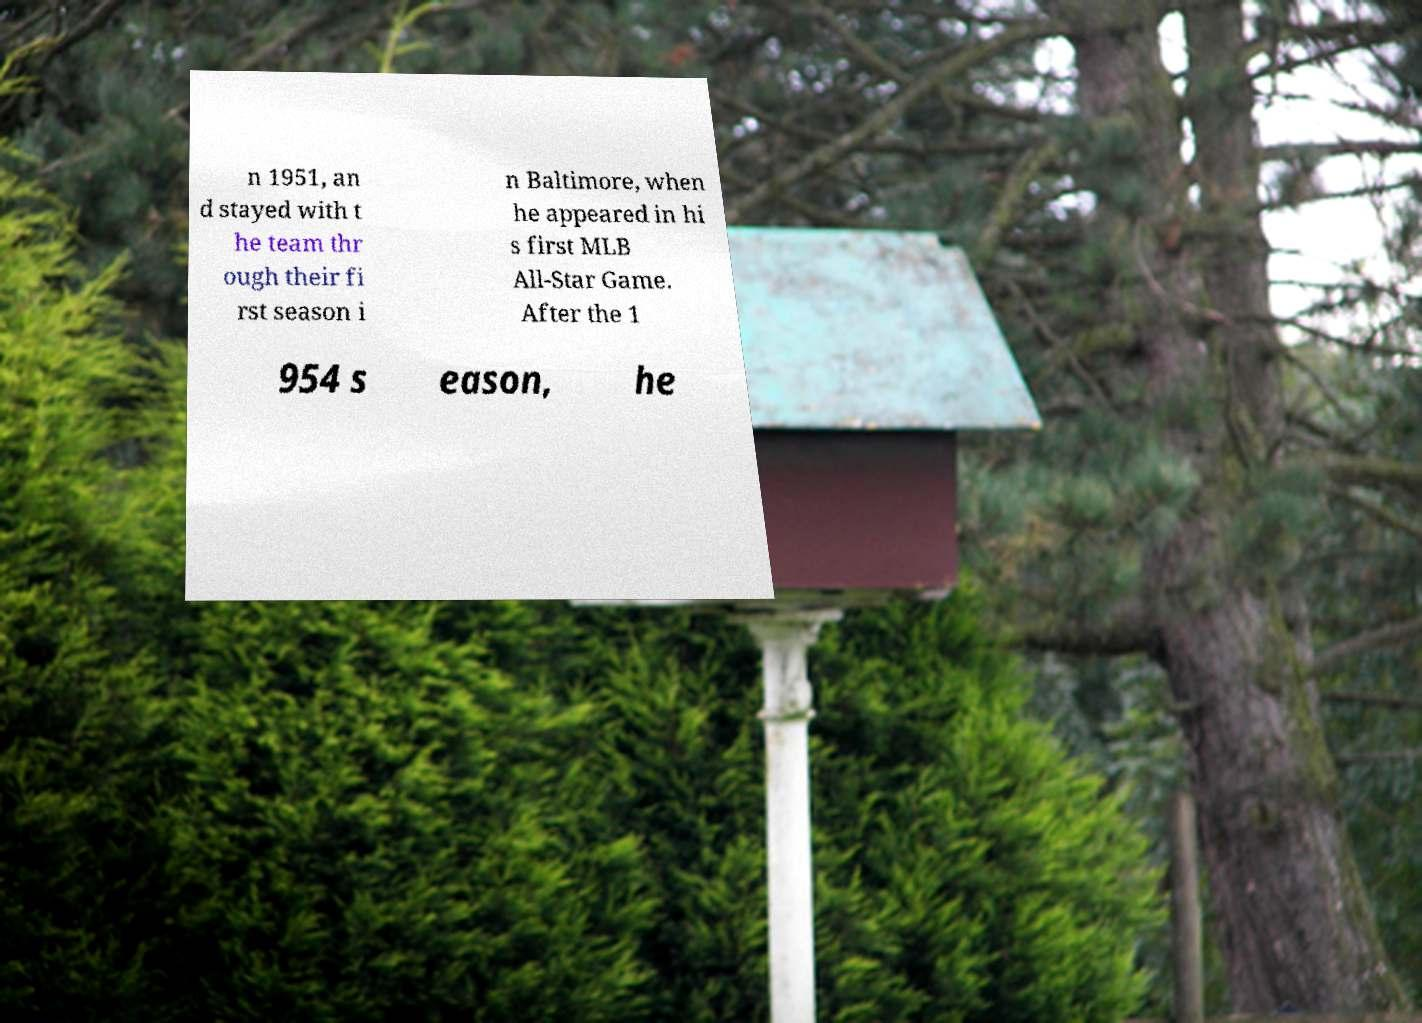Could you extract and type out the text from this image? n 1951, an d stayed with t he team thr ough their fi rst season i n Baltimore, when he appeared in hi s first MLB All-Star Game. After the 1 954 s eason, he 